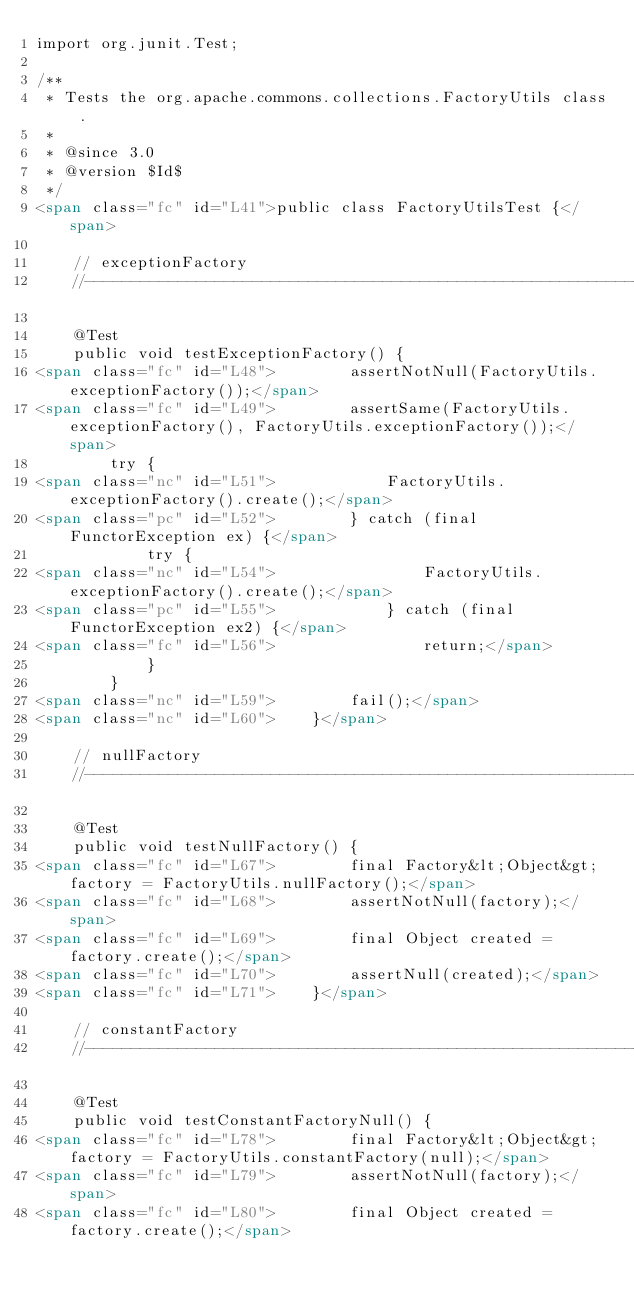Convert code to text. <code><loc_0><loc_0><loc_500><loc_500><_HTML_>import org.junit.Test;

/**
 * Tests the org.apache.commons.collections.FactoryUtils class.
 *
 * @since 3.0
 * @version $Id$
 */
<span class="fc" id="L41">public class FactoryUtilsTest {</span>

    // exceptionFactory
    //------------------------------------------------------------------

    @Test
    public void testExceptionFactory() {
<span class="fc" id="L48">        assertNotNull(FactoryUtils.exceptionFactory());</span>
<span class="fc" id="L49">        assertSame(FactoryUtils.exceptionFactory(), FactoryUtils.exceptionFactory());</span>
        try {
<span class="nc" id="L51">            FactoryUtils.exceptionFactory().create();</span>
<span class="pc" id="L52">        } catch (final FunctorException ex) {</span>
            try {
<span class="nc" id="L54">                FactoryUtils.exceptionFactory().create();</span>
<span class="pc" id="L55">            } catch (final FunctorException ex2) {</span>
<span class="fc" id="L56">                return;</span>
            }
        }
<span class="nc" id="L59">        fail();</span>
<span class="nc" id="L60">    }</span>

    // nullFactory
    //------------------------------------------------------------------

    @Test
    public void testNullFactory() {
<span class="fc" id="L67">        final Factory&lt;Object&gt; factory = FactoryUtils.nullFactory();</span>
<span class="fc" id="L68">        assertNotNull(factory);</span>
<span class="fc" id="L69">        final Object created = factory.create();</span>
<span class="fc" id="L70">        assertNull(created);</span>
<span class="fc" id="L71">    }</span>

    // constantFactory
    //------------------------------------------------------------------

    @Test
    public void testConstantFactoryNull() {
<span class="fc" id="L78">        final Factory&lt;Object&gt; factory = FactoryUtils.constantFactory(null);</span>
<span class="fc" id="L79">        assertNotNull(factory);</span>
<span class="fc" id="L80">        final Object created = factory.create();</span></code> 